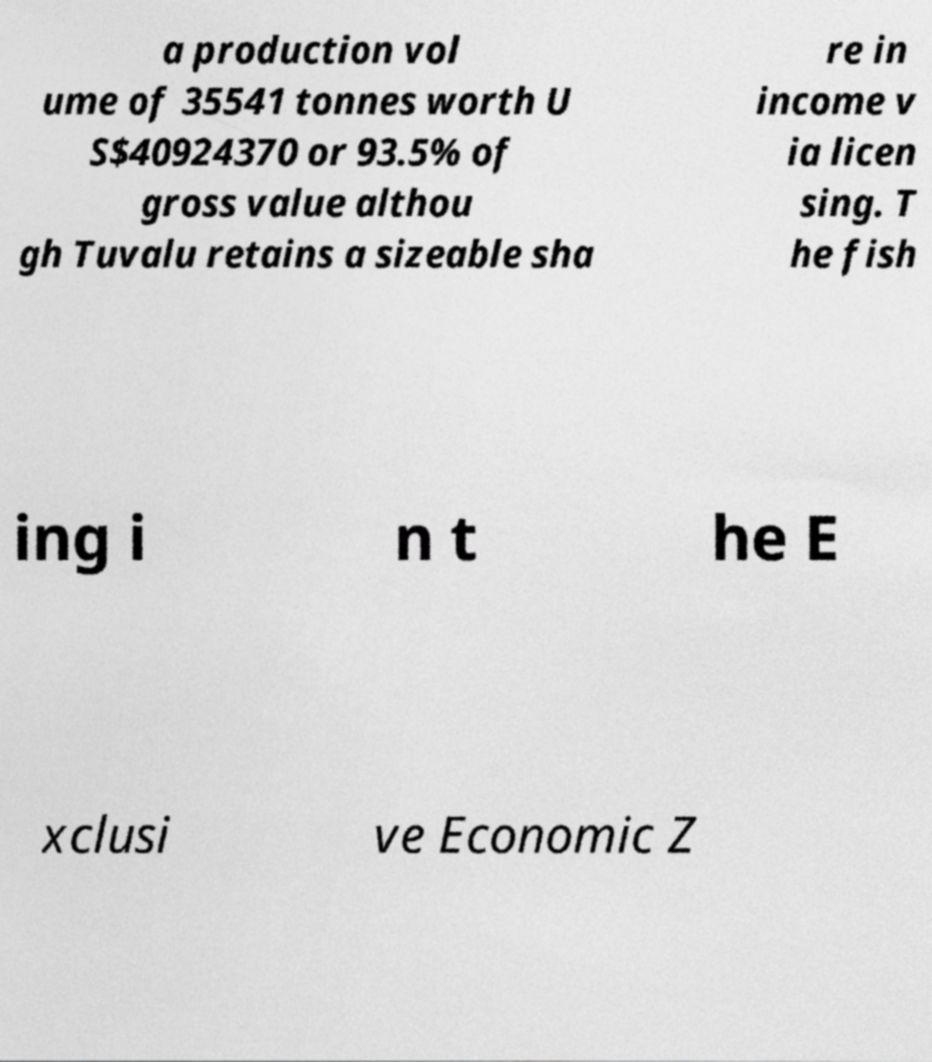What messages or text are displayed in this image? I need them in a readable, typed format. a production vol ume of 35541 tonnes worth U S$40924370 or 93.5% of gross value althou gh Tuvalu retains a sizeable sha re in income v ia licen sing. T he fish ing i n t he E xclusi ve Economic Z 